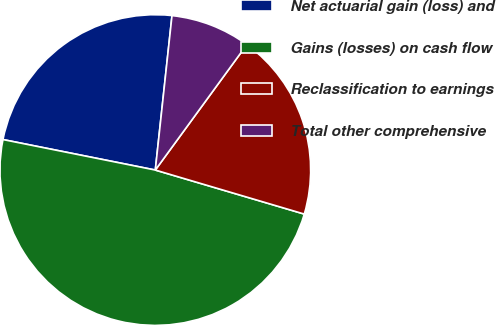Convert chart to OTSL. <chart><loc_0><loc_0><loc_500><loc_500><pie_chart><fcel>Net actuarial gain (loss) and<fcel>Gains (losses) on cash flow<fcel>Reclassification to earnings<fcel>Total other comprehensive<nl><fcel>23.57%<fcel>48.57%<fcel>19.54%<fcel>8.32%<nl></chart> 